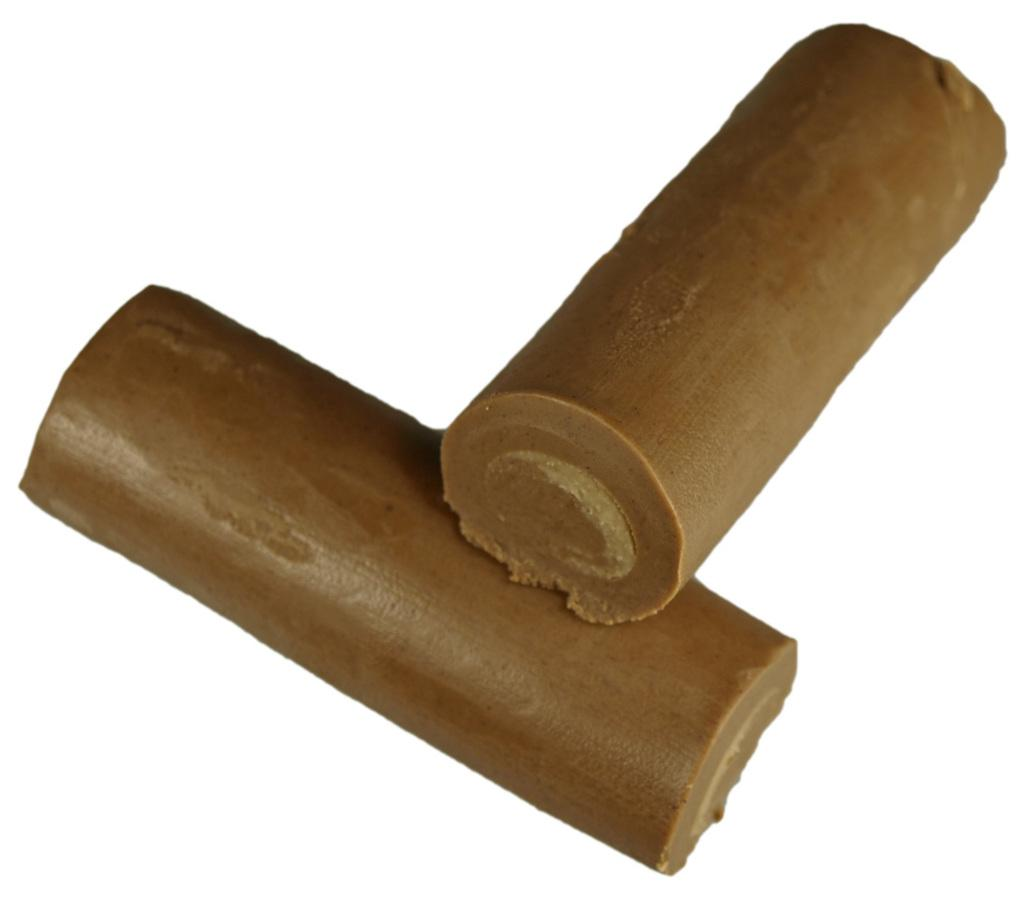What type of food is visible in the image? There are chocolate pieces in the image. What color is the background of the image? The background of the image is white. What type of guide is present in the image? There is no guide present in the image; it only features chocolate pieces and a white background. 